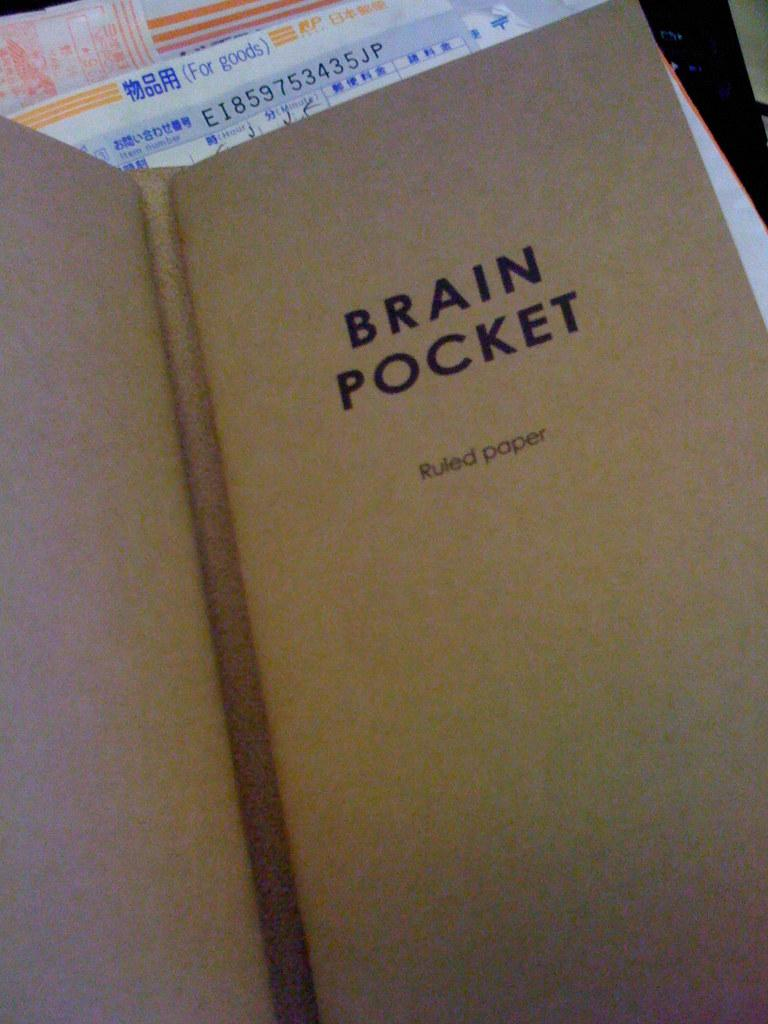Provide a one-sentence caption for the provided image. A book of ruled paper by the brand Brain Pocket. 